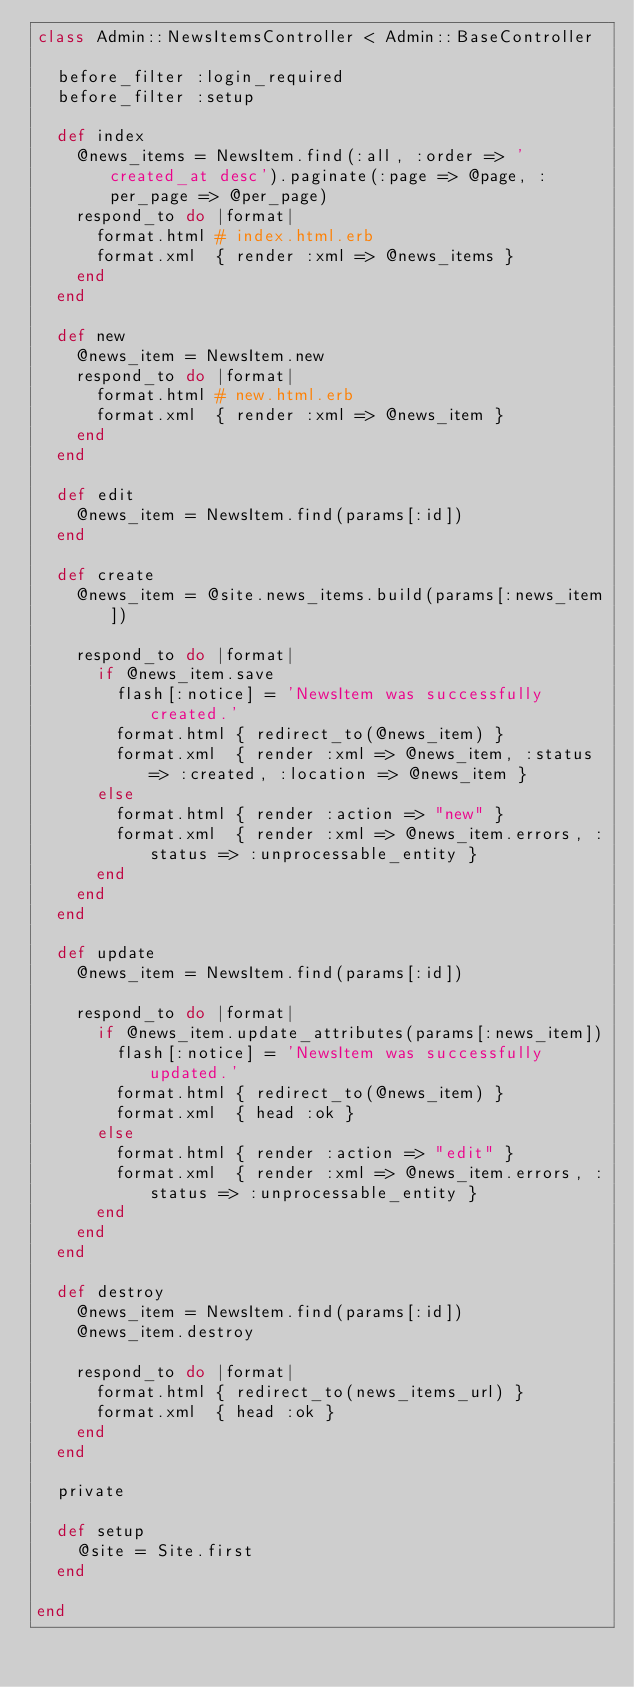<code> <loc_0><loc_0><loc_500><loc_500><_Ruby_>class Admin::NewsItemsController < Admin::BaseController

  before_filter :login_required
  before_filter :setup

  def index
    @news_items = NewsItem.find(:all, :order => 'created_at desc').paginate(:page => @page, :per_page => @per_page)
    respond_to do |format|
      format.html # index.html.erb
      format.xml  { render :xml => @news_items }
    end
  end

  def new
    @news_item = NewsItem.new
    respond_to do |format|
      format.html # new.html.erb
      format.xml  { render :xml => @news_item }
    end
  end

  def edit
    @news_item = NewsItem.find(params[:id])
  end

  def create
    @news_item = @site.news_items.build(params[:news_item])

    respond_to do |format|
      if @news_item.save
        flash[:notice] = 'NewsItem was successfully created.'
        format.html { redirect_to(@news_item) }
        format.xml  { render :xml => @news_item, :status => :created, :location => @news_item }
      else
        format.html { render :action => "new" }
        format.xml  { render :xml => @news_item.errors, :status => :unprocessable_entity }
      end
    end
  end

  def update
    @news_item = NewsItem.find(params[:id])

    respond_to do |format|
      if @news_item.update_attributes(params[:news_item])
        flash[:notice] = 'NewsItem was successfully updated.'
        format.html { redirect_to(@news_item) }
        format.xml  { head :ok }
      else
        format.html { render :action => "edit" }
        format.xml  { render :xml => @news_item.errors, :status => :unprocessable_entity }
      end
    end
  end

  def destroy
    @news_item = NewsItem.find(params[:id])
    @news_item.destroy

    respond_to do |format|
      format.html { redirect_to(news_items_url) }
      format.xml  { head :ok }
    end
  end

  private

  def setup
    @site = Site.first
  end

end
</code> 